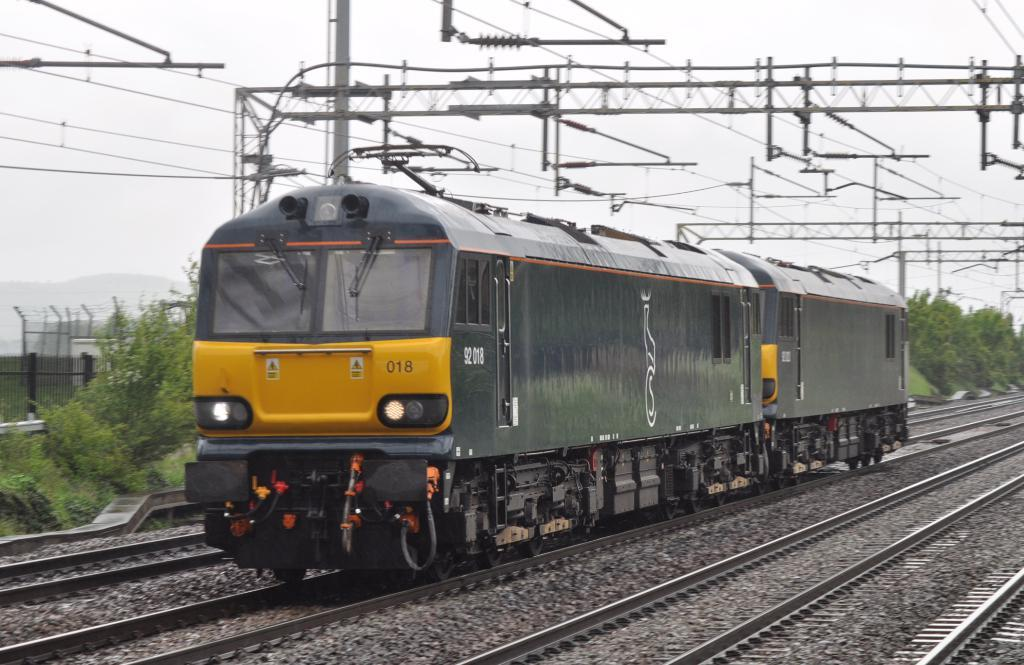Provide a one-sentence caption for the provided image. A train has the number 18 on the front and is on tracks. 